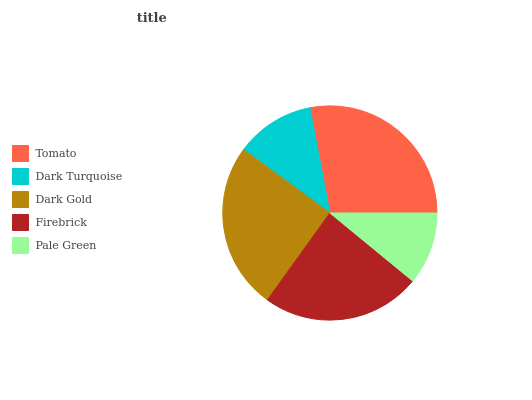Is Pale Green the minimum?
Answer yes or no. Yes. Is Tomato the maximum?
Answer yes or no. Yes. Is Dark Turquoise the minimum?
Answer yes or no. No. Is Dark Turquoise the maximum?
Answer yes or no. No. Is Tomato greater than Dark Turquoise?
Answer yes or no. Yes. Is Dark Turquoise less than Tomato?
Answer yes or no. Yes. Is Dark Turquoise greater than Tomato?
Answer yes or no. No. Is Tomato less than Dark Turquoise?
Answer yes or no. No. Is Firebrick the high median?
Answer yes or no. Yes. Is Firebrick the low median?
Answer yes or no. Yes. Is Pale Green the high median?
Answer yes or no. No. Is Dark Turquoise the low median?
Answer yes or no. No. 